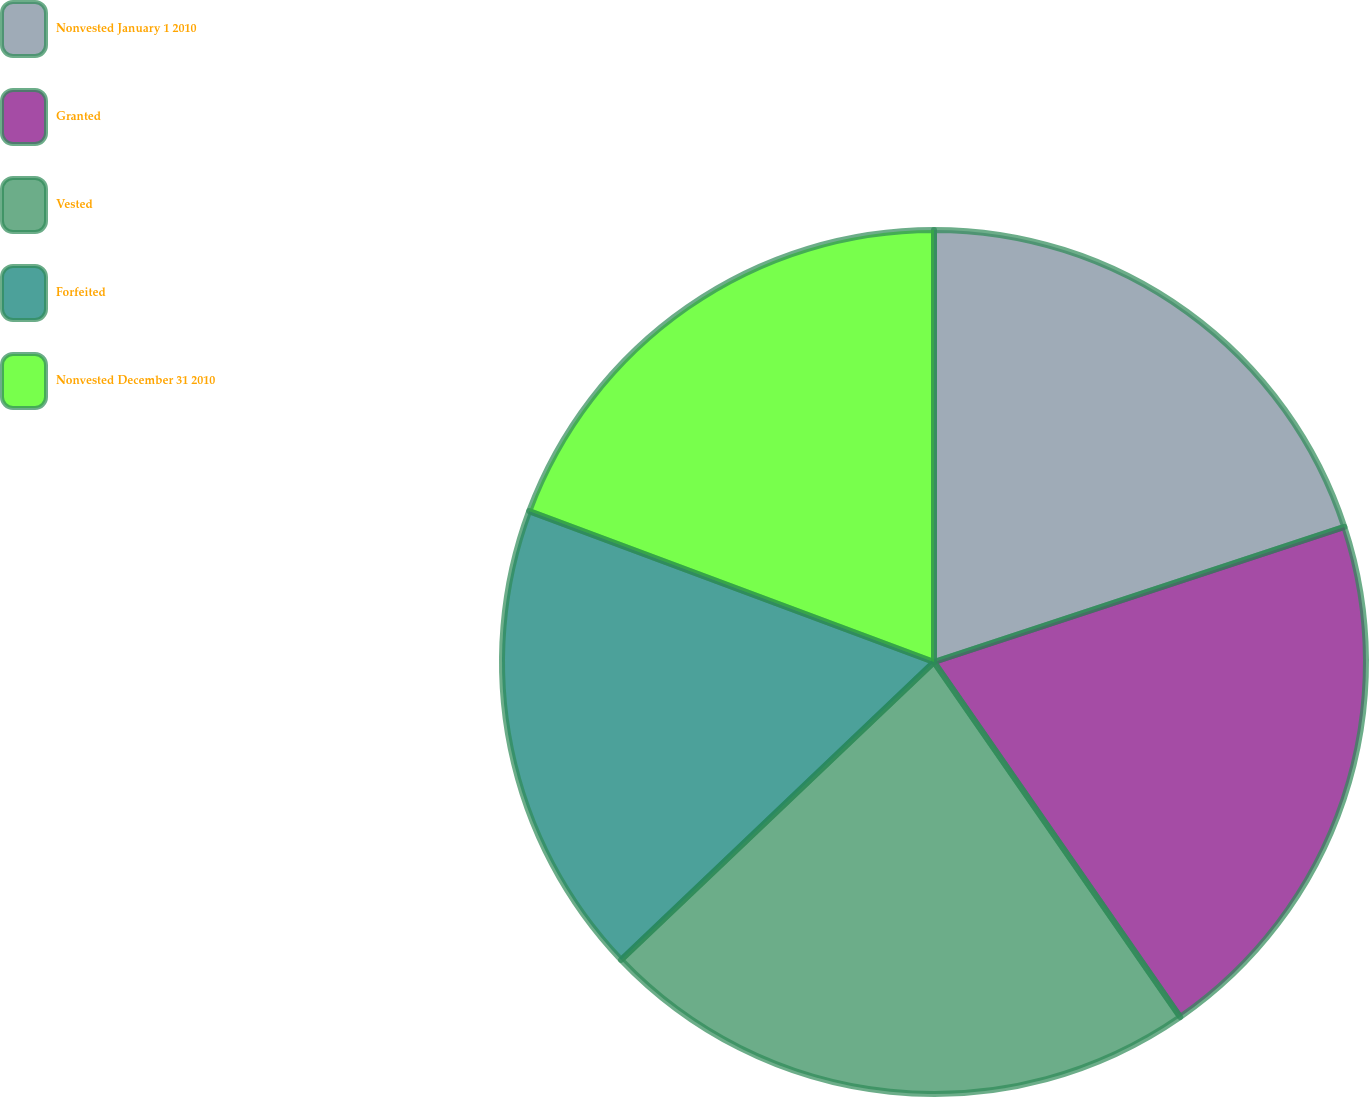<chart> <loc_0><loc_0><loc_500><loc_500><pie_chart><fcel>Nonvested January 1 2010<fcel>Granted<fcel>Vested<fcel>Forfeited<fcel>Nonvested December 31 2010<nl><fcel>19.94%<fcel>20.41%<fcel>22.54%<fcel>17.79%<fcel>19.32%<nl></chart> 